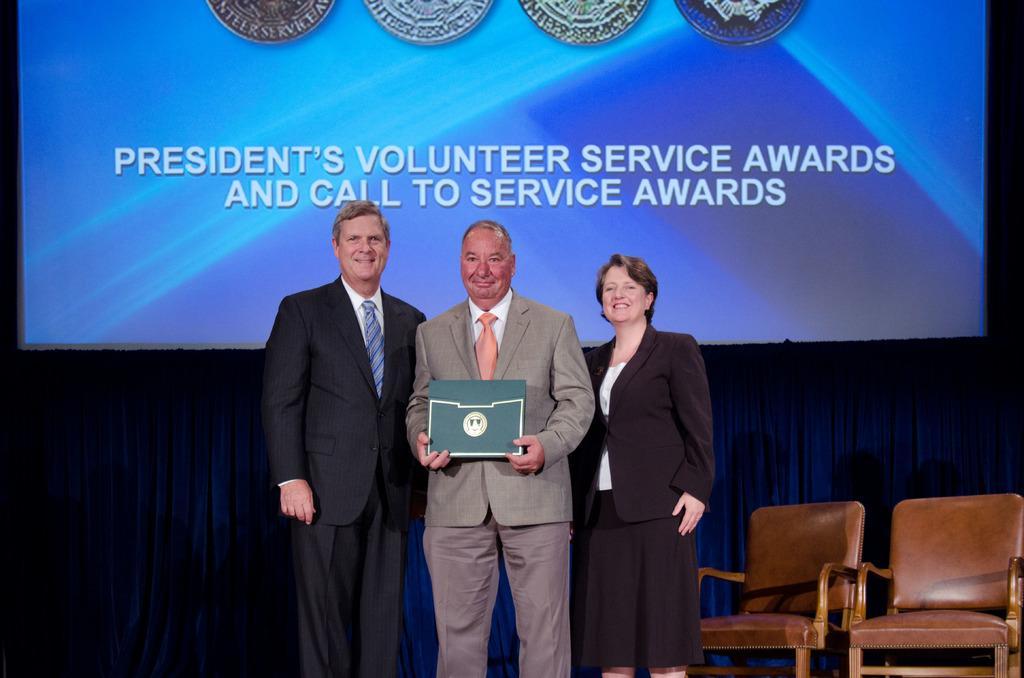In one or two sentences, can you explain what this image depicts? In this image, there are three persons standing and wearing clothes. The person who is in the center of the image holding something. There is a screen at the top of the image. There are two chairs in the bottom right of the image. 